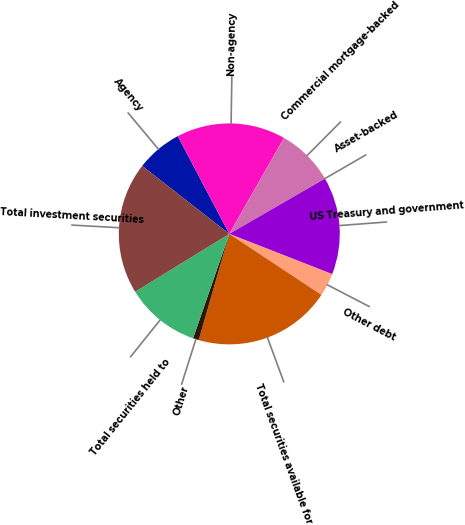Convert chart to OTSL. <chart><loc_0><loc_0><loc_500><loc_500><pie_chart><fcel>Agency<fcel>Non-agency<fcel>Commercial mortgage-backed<fcel>Asset-backed<fcel>US Treasury and government<fcel>Other debt<fcel>Total securities available for<fcel>Other<fcel>Total securities held to<fcel>Total investment securities<nl><fcel>6.73%<fcel>15.96%<fcel>8.41%<fcel>0.01%<fcel>14.28%<fcel>3.37%<fcel>20.16%<fcel>0.85%<fcel>10.92%<fcel>19.32%<nl></chart> 